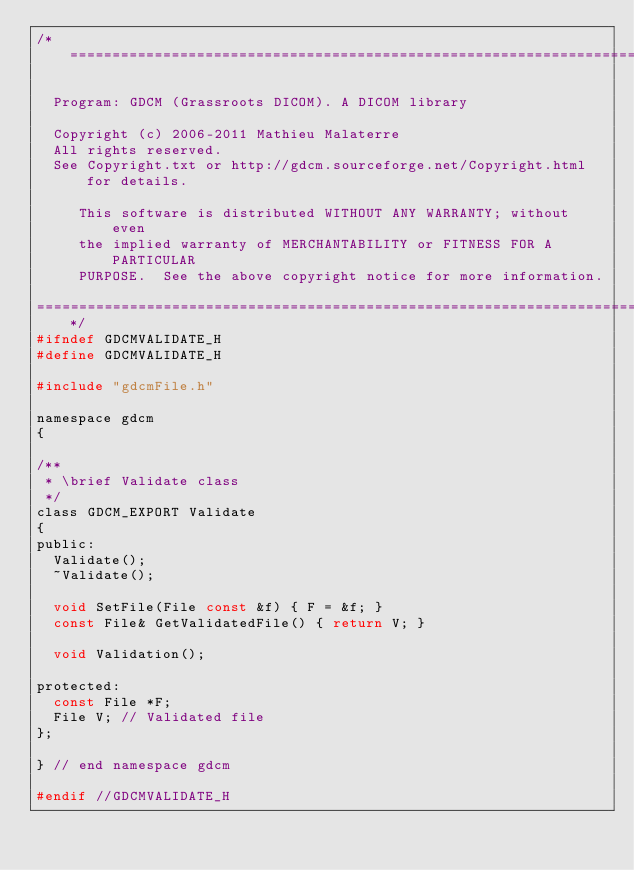<code> <loc_0><loc_0><loc_500><loc_500><_C_>/*=========================================================================

  Program: GDCM (Grassroots DICOM). A DICOM library

  Copyright (c) 2006-2011 Mathieu Malaterre
  All rights reserved.
  See Copyright.txt or http://gdcm.sourceforge.net/Copyright.html for details.

     This software is distributed WITHOUT ANY WARRANTY; without even
     the implied warranty of MERCHANTABILITY or FITNESS FOR A PARTICULAR
     PURPOSE.  See the above copyright notice for more information.

=========================================================================*/
#ifndef GDCMVALIDATE_H
#define GDCMVALIDATE_H

#include "gdcmFile.h"

namespace gdcm
{

/**
 * \brief Validate class
 */
class GDCM_EXPORT Validate
{
public:
  Validate();
  ~Validate();

  void SetFile(File const &f) { F = &f; }
  const File& GetValidatedFile() { return V; }

  void Validation();

protected:
  const File *F;
  File V; // Validated file
};

} // end namespace gdcm

#endif //GDCMVALIDATE_H
</code> 